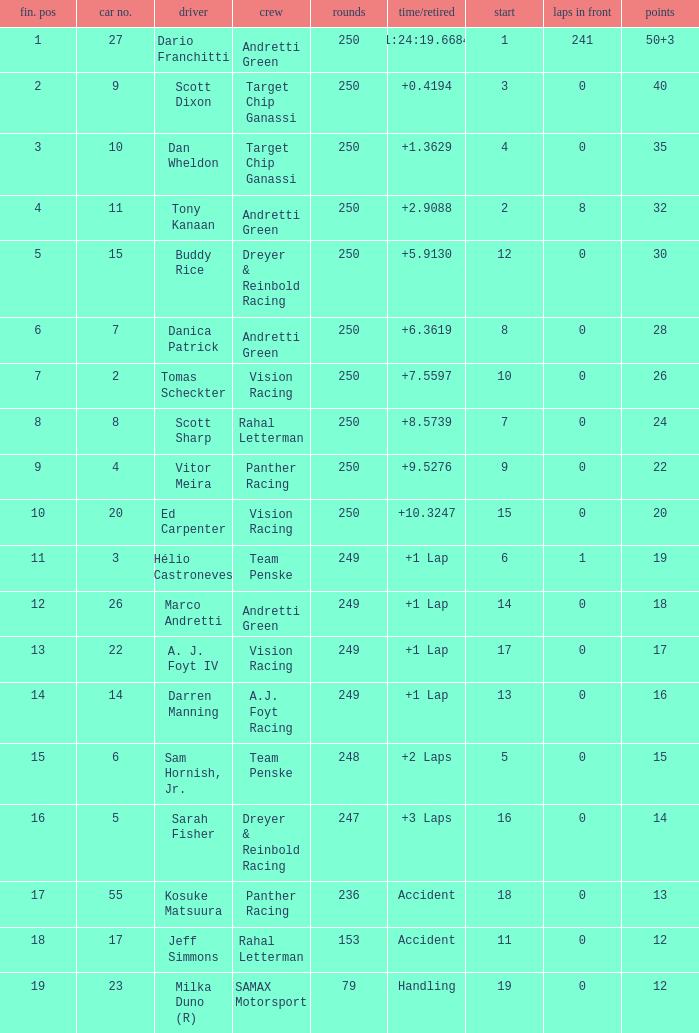Name the total number of cars for panther racing and grid of 9 1.0. 